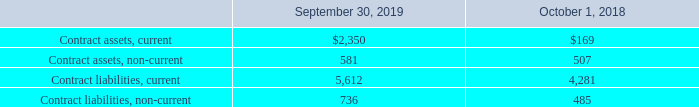Contract Balances
The following table provides information about contract assets and contract liabilities from contracts with customers (amounts in thousands):
Contract assets, reported within current assets and other long-term assets in the consolidated balance sheets, primarily result from revenue being recognized when a license is delivered and payments are made over time. Contract liabilities primarily relate to advance consideration received from customers, deferred revenue, for which transfer of control occurs, and therefore revenue is recognized, as services are provided. Contract balances are reported in a net contract asset or liability position on a contract-by-contract basis at the end of each reporting period. The Company recognized $4.4 million of revenue during the year ended September 30, 2019 that was included in the contract liability balance at the beginning of the period.
What are the balances of current contract assets and liabilities as of September 30, 2019, respectively?
Answer scale should be: thousand. $2,350, 5,612. What do contract liabilities primarily relate to? Advance consideration received from customers, deferred revenue, for which transfer of control occurs, and therefore revenue is recognized, as services are provided. How are contract balances being reported? In a net contract asset or liability position on a contract-by-contract basis at the end of each reporting period. What is the percentage change of total balances of contract assets, including current and non-current, from 2018 to 2019?
Answer scale should be: percent. ((2,350+581)-(169+507))/(169+507) 
Answer: 333.58. What is the total balance of contract assets and liabilities in 2019?
Answer scale should be: thousand. 2,350+581+5,612+736 
Answer: 9279. What is the ratio of contract liabilities to contract assets in 2018? (4,281+485)/(169+507) 
Answer: 7.05. 